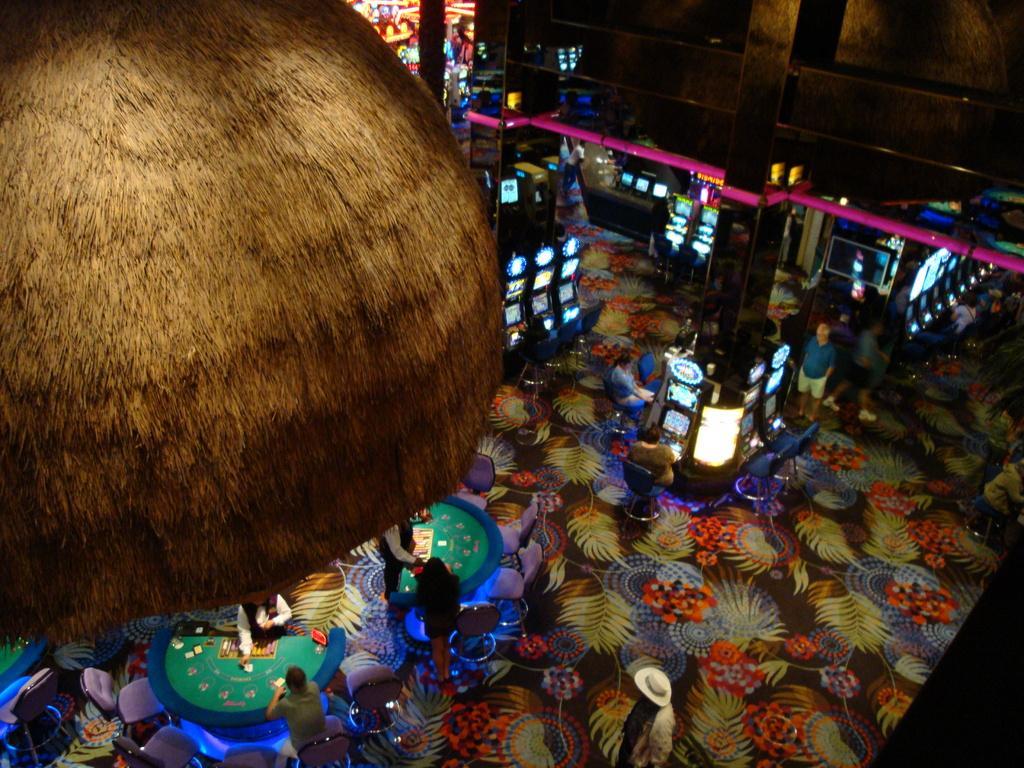How would you summarize this image in a sentence or two? In this image there are some persons some of them are sitting on chairs, and some of them are standing and also there are some tables. On the tables there are some cards and some other objects, on the left side it looks like a hut, and in the background there is wall, lights, monitors and some other objects. 